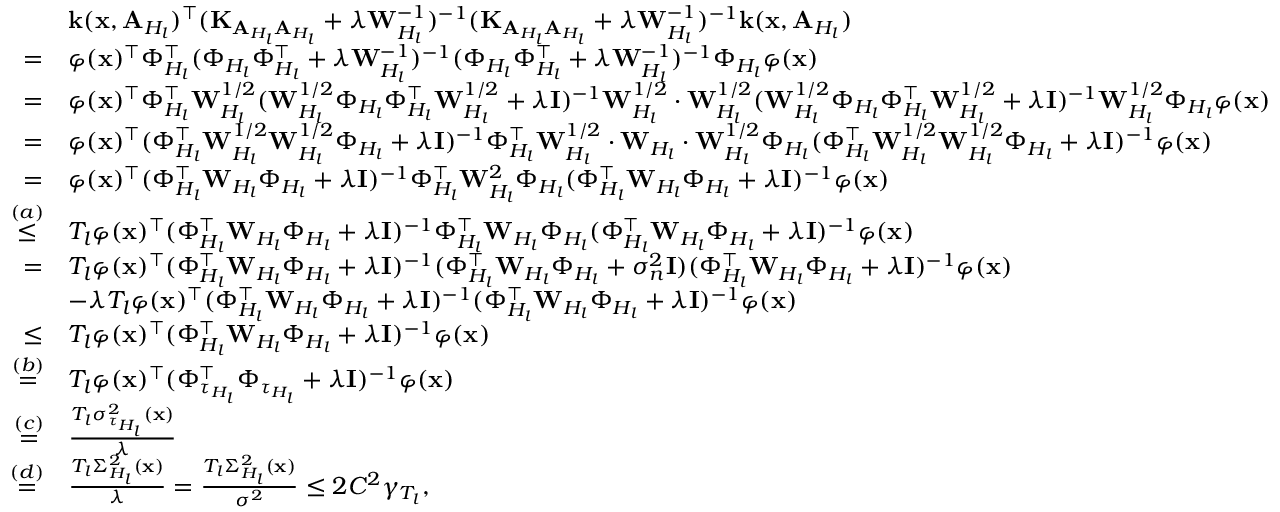Convert formula to latex. <formula><loc_0><loc_0><loc_500><loc_500>\begin{array} { r l } & { k ( x , A _ { H _ { l } } ) ^ { \top } ( K _ { A _ { H _ { l } } A _ { H _ { l } } } + \lambda W _ { H _ { l } } ^ { - 1 } ) ^ { - 1 } ( K _ { A _ { H _ { l } } A _ { H _ { l } } } + \lambda W _ { H _ { l } } ^ { - 1 } ) ^ { - 1 } k ( x , A _ { H _ { l } } ) } \\ { = } & { \varphi ( x ) ^ { \top } \Phi _ { H _ { l } } ^ { \top } ( \Phi _ { H _ { l } } \Phi _ { H _ { l } } ^ { \top } + \lambda W _ { H _ { l } } ^ { - 1 } ) ^ { - 1 } ( \Phi _ { H _ { l } } \Phi _ { H _ { l } } ^ { \top } + \lambda W _ { H _ { l } } ^ { - 1 } ) ^ { - 1 } \Phi _ { H _ { l } } \varphi ( x ) } \\ { = } & { \varphi ( x ) ^ { \top } \Phi _ { H _ { l } } ^ { \top } W _ { H _ { l } } ^ { 1 / 2 } ( W _ { H _ { l } } ^ { 1 / 2 } \Phi _ { H _ { l } } \Phi _ { H _ { l } } ^ { \top } W _ { H _ { l } } ^ { 1 / 2 } + \lambda I ) ^ { - 1 } W _ { H _ { l } } ^ { 1 / 2 } \cdot W _ { H _ { l } } ^ { 1 / 2 } ( W _ { H _ { l } } ^ { 1 / 2 } \Phi _ { H _ { l } } \Phi _ { H _ { l } } ^ { \top } W _ { H _ { l } } ^ { 1 / 2 } + \lambda I ) ^ { - 1 } W _ { H _ { l } } ^ { 1 / 2 } \Phi _ { H _ { l } } \varphi ( x ) } \\ { = } & { \varphi ( x ) ^ { \top } ( \Phi _ { H _ { l } } ^ { \top } W _ { H _ { l } } ^ { 1 / 2 } W _ { H _ { l } } ^ { 1 / 2 } \Phi _ { H _ { l } } + \lambda I ) ^ { - 1 } \Phi _ { H _ { l } } ^ { \top } W _ { H _ { l } } ^ { 1 / 2 } \cdot W _ { H _ { l } } \cdot W _ { H _ { l } } ^ { 1 / 2 } \Phi _ { H _ { l } } ( \Phi _ { H _ { l } } ^ { \top } W _ { H _ { l } } ^ { 1 / 2 } W _ { H _ { l } } ^ { 1 / 2 } \Phi _ { H _ { l } } + \lambda I ) ^ { - 1 } \varphi ( x ) } \\ { = } & { \varphi ( x ) ^ { \top } ( \Phi _ { H _ { l } } ^ { \top } W _ { H _ { l } } \Phi _ { H _ { l } } + \lambda I ) ^ { - 1 } \Phi _ { H _ { l } } ^ { \top } W _ { H _ { l } } ^ { 2 } \Phi _ { H _ { l } } ( \Phi _ { H _ { l } } ^ { \top } W _ { H _ { l } } \Phi _ { H _ { l } } + \lambda I ) ^ { - 1 } \varphi ( x ) } \\ { \overset { ( a ) } { \leq } } & { T _ { l } \varphi ( x ) ^ { \top } ( \Phi _ { H _ { l } } ^ { \top } W _ { H _ { l } } \Phi _ { H _ { l } } + \lambda I ) ^ { - 1 } \Phi _ { H _ { l } } ^ { \top } W _ { H _ { l } } \Phi _ { H _ { l } } ( \Phi _ { H _ { l } } ^ { \top } W _ { H _ { l } } \Phi _ { H _ { l } } + \lambda I ) ^ { - 1 } \varphi ( x ) } \\ { = } & { T _ { l } \varphi ( x ) ^ { \top } ( \Phi _ { H _ { l } } ^ { \top } W _ { H _ { l } } \Phi _ { H _ { l } } + \lambda I ) ^ { - 1 } ( \Phi _ { H _ { l } } ^ { \top } W _ { H _ { l } } \Phi _ { H _ { l } } + \sigma _ { n } ^ { 2 } I ) ( \Phi _ { H _ { l } } ^ { \top } W _ { H _ { l } } \Phi _ { H _ { l } } + \lambda I ) ^ { - 1 } \varphi ( x ) } \\ & { - \lambda T _ { l } \varphi ( x ) ^ { \top } ( \Phi _ { H _ { l } } ^ { \top } W _ { H _ { l } } \Phi _ { H _ { l } } + \lambda I ) ^ { - 1 } ( \Phi _ { H _ { l } } ^ { \top } W _ { H _ { l } } \Phi _ { H _ { l } } + \lambda I ) ^ { - 1 } \varphi ( x ) } \\ { \leq } & { T _ { l } \varphi ( x ) ^ { \top } ( \Phi _ { H _ { l } } ^ { \top } W _ { H _ { l } } \Phi _ { H _ { l } } + \lambda I ) ^ { - 1 } \varphi ( x ) } \\ { \overset { ( b ) } { = } } & { T _ { l } \varphi ( x ) ^ { \top } ( \Phi _ { \tau _ { H _ { l } } } ^ { \top } \Phi _ { \tau _ { H _ { l } } } + \lambda I ) ^ { - 1 } \varphi ( x ) } \\ { \overset { ( c ) } { = } } & { \frac { T _ { l } \sigma _ { \tau _ { H _ { l } } } ^ { 2 } ( x ) } { \lambda } } \\ { \overset { ( d ) } { = } } & { \frac { T _ { l } \Sigma _ { H _ { l } } ^ { 2 } ( x ) } { \lambda } = \frac { T _ { l } \Sigma _ { H _ { l } } ^ { 2 } ( x ) } { \sigma ^ { 2 } } \leq 2 C ^ { 2 } \gamma _ { T _ { l } } , } \end{array}</formula> 